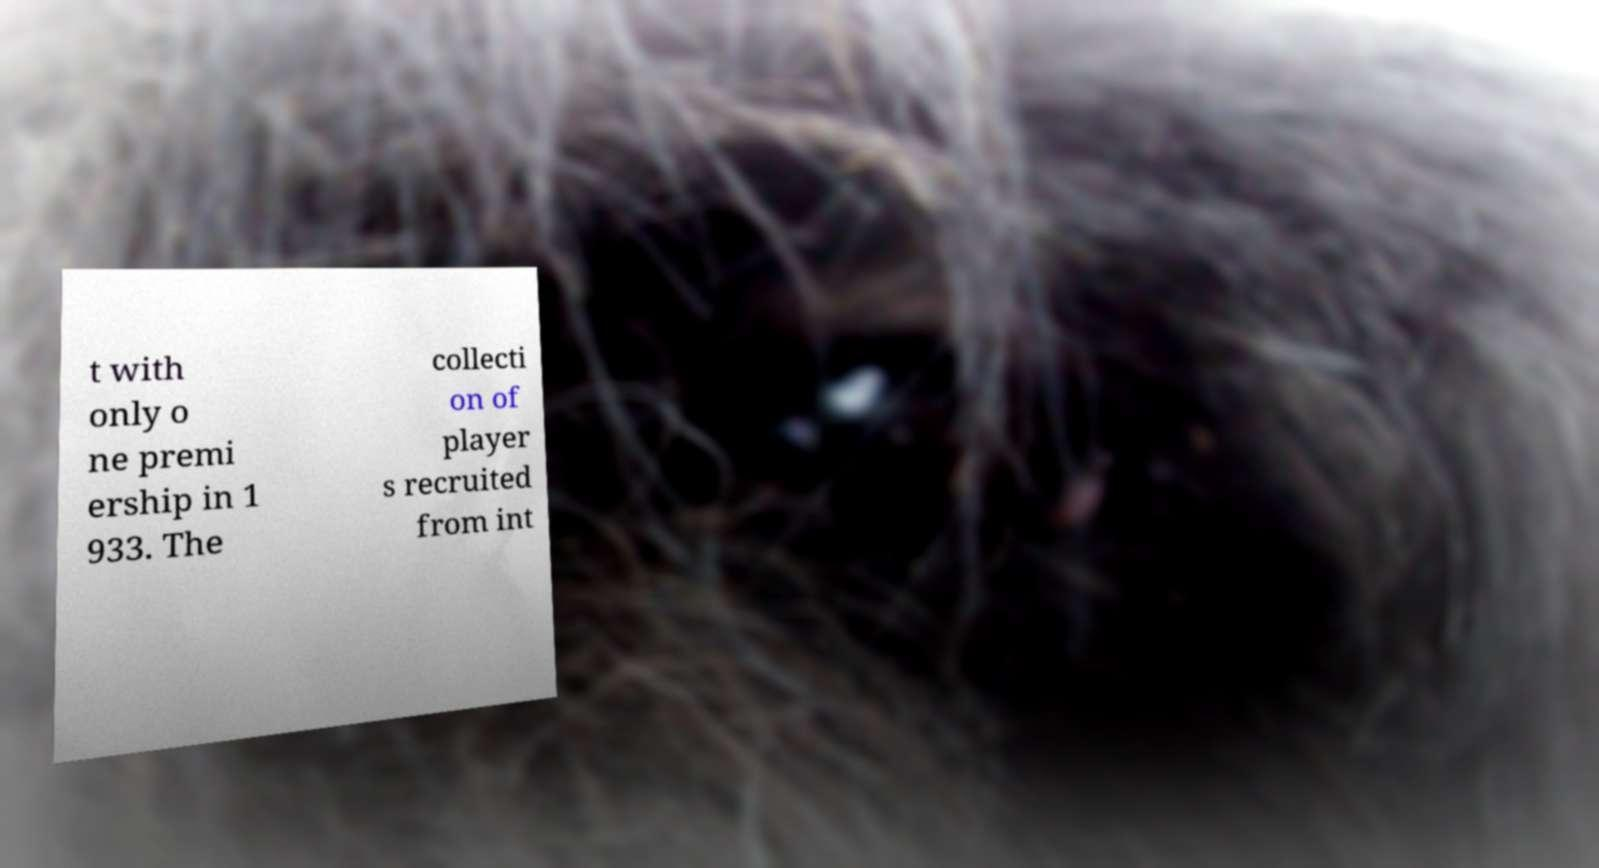Could you extract and type out the text from this image? t with only o ne premi ership in 1 933. The collecti on of player s recruited from int 